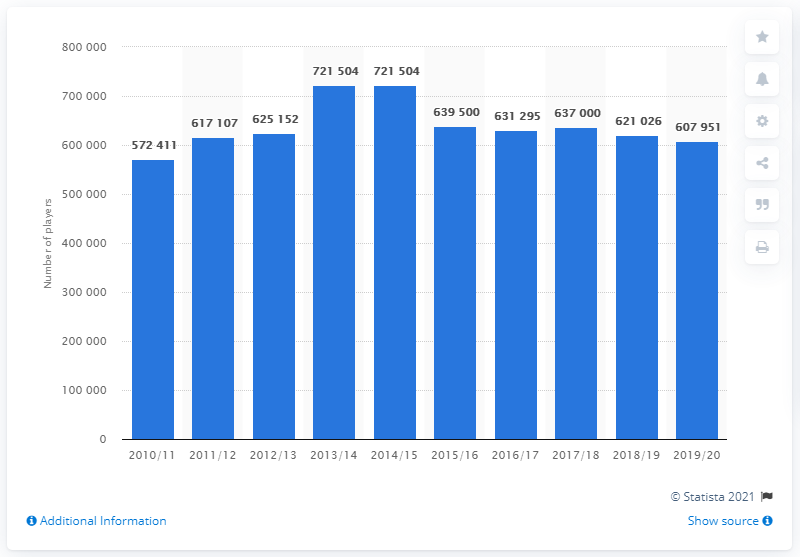Identify some key points in this picture. In the 2010-2011 season, a total of 572,411 registered ice hockey players were recorded in Canada. In the years 2010-2012, there were a total of 1,189,518 registered ice hockey players in Canada, as recorded by official sources. 